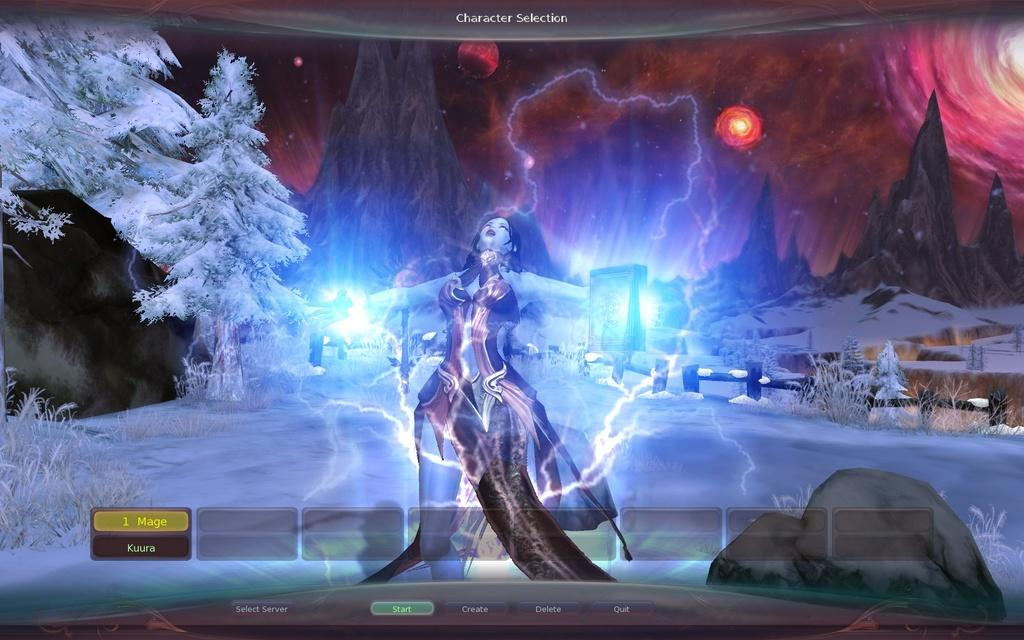Who is present in the image? There is a woman in the image. Has the image been altered in any way? Yes, the image has been edited. What can be seen in the background of the image? There are trees with snow in the background of the image. What type of cheese is the woman holding in the image? There is no cheese present in the image; the woman is not holding anything. 